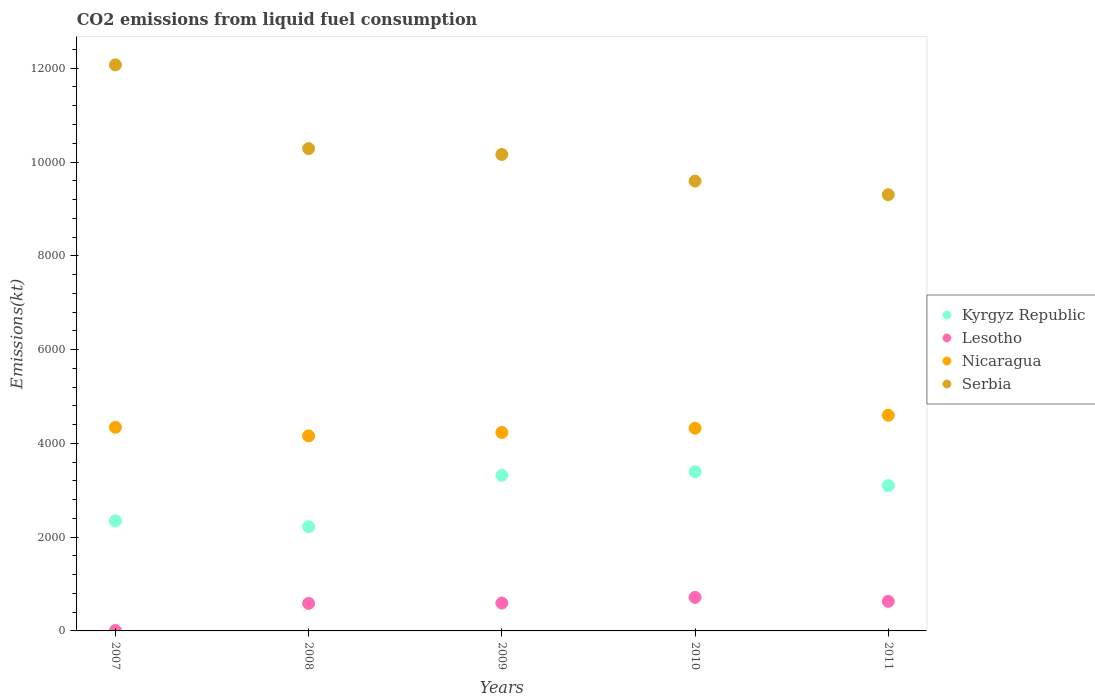What is the amount of CO2 emitted in Kyrgyz Republic in 2007?
Give a very brief answer. 2346.88. Across all years, what is the maximum amount of CO2 emitted in Kyrgyz Republic?
Offer a very short reply. 3395.64. Across all years, what is the minimum amount of CO2 emitted in Kyrgyz Republic?
Offer a very short reply. 2222.2. What is the total amount of CO2 emitted in Serbia in the graph?
Provide a succinct answer. 5.14e+04. What is the difference between the amount of CO2 emitted in Nicaragua in 2010 and that in 2011?
Your answer should be very brief. -275.02. What is the difference between the amount of CO2 emitted in Lesotho in 2010 and the amount of CO2 emitted in Kyrgyz Republic in 2009?
Make the answer very short. -2603.57. What is the average amount of CO2 emitted in Nicaragua per year?
Give a very brief answer. 4330.73. In the year 2007, what is the difference between the amount of CO2 emitted in Nicaragua and amount of CO2 emitted in Serbia?
Keep it short and to the point. -7730.04. What is the ratio of the amount of CO2 emitted in Nicaragua in 2007 to that in 2010?
Your answer should be compact. 1. Is the amount of CO2 emitted in Serbia in 2007 less than that in 2010?
Offer a terse response. No. What is the difference between the highest and the second highest amount of CO2 emitted in Lesotho?
Provide a short and direct response. 84.34. What is the difference between the highest and the lowest amount of CO2 emitted in Nicaragua?
Offer a very short reply. 440.04. Is the sum of the amount of CO2 emitted in Lesotho in 2007 and 2008 greater than the maximum amount of CO2 emitted in Serbia across all years?
Your answer should be compact. No. Is it the case that in every year, the sum of the amount of CO2 emitted in Kyrgyz Republic and amount of CO2 emitted in Serbia  is greater than the amount of CO2 emitted in Lesotho?
Ensure brevity in your answer.  Yes. Is the amount of CO2 emitted in Nicaragua strictly greater than the amount of CO2 emitted in Kyrgyz Republic over the years?
Keep it short and to the point. Yes. Is the amount of CO2 emitted in Nicaragua strictly less than the amount of CO2 emitted in Serbia over the years?
Keep it short and to the point. Yes. How many years are there in the graph?
Offer a very short reply. 5. What is the difference between two consecutive major ticks on the Y-axis?
Provide a short and direct response. 2000. What is the title of the graph?
Give a very brief answer. CO2 emissions from liquid fuel consumption. Does "Italy" appear as one of the legend labels in the graph?
Your answer should be compact. No. What is the label or title of the Y-axis?
Make the answer very short. Emissions(kt). What is the Emissions(kt) in Kyrgyz Republic in 2007?
Provide a short and direct response. 2346.88. What is the Emissions(kt) in Lesotho in 2007?
Make the answer very short. 7.33. What is the Emissions(kt) of Nicaragua in 2007?
Provide a short and direct response. 4341.73. What is the Emissions(kt) of Serbia in 2007?
Make the answer very short. 1.21e+04. What is the Emissions(kt) in Kyrgyz Republic in 2008?
Your answer should be very brief. 2222.2. What is the Emissions(kt) in Lesotho in 2008?
Offer a terse response. 586.72. What is the Emissions(kt) of Nicaragua in 2008?
Give a very brief answer. 4158.38. What is the Emissions(kt) of Serbia in 2008?
Provide a short and direct response. 1.03e+04. What is the Emissions(kt) in Kyrgyz Republic in 2009?
Make the answer very short. 3318.64. What is the Emissions(kt) in Lesotho in 2009?
Offer a very short reply. 594.05. What is the Emissions(kt) of Nicaragua in 2009?
Keep it short and to the point. 4231.72. What is the Emissions(kt) in Serbia in 2009?
Your answer should be compact. 1.02e+04. What is the Emissions(kt) of Kyrgyz Republic in 2010?
Make the answer very short. 3395.64. What is the Emissions(kt) of Lesotho in 2010?
Your answer should be compact. 715.07. What is the Emissions(kt) of Nicaragua in 2010?
Keep it short and to the point. 4323.39. What is the Emissions(kt) of Serbia in 2010?
Your answer should be very brief. 9592.87. What is the Emissions(kt) of Kyrgyz Republic in 2011?
Keep it short and to the point. 3098.61. What is the Emissions(kt) of Lesotho in 2011?
Your answer should be compact. 630.72. What is the Emissions(kt) in Nicaragua in 2011?
Your response must be concise. 4598.42. What is the Emissions(kt) in Serbia in 2011?
Your answer should be very brief. 9303.18. Across all years, what is the maximum Emissions(kt) of Kyrgyz Republic?
Offer a terse response. 3395.64. Across all years, what is the maximum Emissions(kt) of Lesotho?
Give a very brief answer. 715.07. Across all years, what is the maximum Emissions(kt) in Nicaragua?
Provide a succinct answer. 4598.42. Across all years, what is the maximum Emissions(kt) in Serbia?
Offer a terse response. 1.21e+04. Across all years, what is the minimum Emissions(kt) in Kyrgyz Republic?
Your answer should be very brief. 2222.2. Across all years, what is the minimum Emissions(kt) in Lesotho?
Give a very brief answer. 7.33. Across all years, what is the minimum Emissions(kt) in Nicaragua?
Make the answer very short. 4158.38. Across all years, what is the minimum Emissions(kt) of Serbia?
Offer a terse response. 9303.18. What is the total Emissions(kt) in Kyrgyz Republic in the graph?
Offer a terse response. 1.44e+04. What is the total Emissions(kt) in Lesotho in the graph?
Your answer should be very brief. 2533.9. What is the total Emissions(kt) in Nicaragua in the graph?
Provide a succinct answer. 2.17e+04. What is the total Emissions(kt) in Serbia in the graph?
Your response must be concise. 5.14e+04. What is the difference between the Emissions(kt) in Kyrgyz Republic in 2007 and that in 2008?
Your answer should be very brief. 124.68. What is the difference between the Emissions(kt) in Lesotho in 2007 and that in 2008?
Offer a terse response. -579.39. What is the difference between the Emissions(kt) in Nicaragua in 2007 and that in 2008?
Your answer should be very brief. 183.35. What is the difference between the Emissions(kt) in Serbia in 2007 and that in 2008?
Provide a short and direct response. 1785.83. What is the difference between the Emissions(kt) in Kyrgyz Republic in 2007 and that in 2009?
Offer a terse response. -971.75. What is the difference between the Emissions(kt) of Lesotho in 2007 and that in 2009?
Provide a succinct answer. -586.72. What is the difference between the Emissions(kt) of Nicaragua in 2007 and that in 2009?
Provide a succinct answer. 110.01. What is the difference between the Emissions(kt) in Serbia in 2007 and that in 2009?
Ensure brevity in your answer.  1910.51. What is the difference between the Emissions(kt) in Kyrgyz Republic in 2007 and that in 2010?
Your answer should be compact. -1048.76. What is the difference between the Emissions(kt) of Lesotho in 2007 and that in 2010?
Your answer should be compact. -707.73. What is the difference between the Emissions(kt) of Nicaragua in 2007 and that in 2010?
Your answer should be compact. 18.34. What is the difference between the Emissions(kt) in Serbia in 2007 and that in 2010?
Give a very brief answer. 2478.89. What is the difference between the Emissions(kt) in Kyrgyz Republic in 2007 and that in 2011?
Offer a very short reply. -751.74. What is the difference between the Emissions(kt) in Lesotho in 2007 and that in 2011?
Offer a very short reply. -623.39. What is the difference between the Emissions(kt) of Nicaragua in 2007 and that in 2011?
Offer a very short reply. -256.69. What is the difference between the Emissions(kt) of Serbia in 2007 and that in 2011?
Ensure brevity in your answer.  2768.59. What is the difference between the Emissions(kt) in Kyrgyz Republic in 2008 and that in 2009?
Your answer should be very brief. -1096.43. What is the difference between the Emissions(kt) of Lesotho in 2008 and that in 2009?
Offer a terse response. -7.33. What is the difference between the Emissions(kt) in Nicaragua in 2008 and that in 2009?
Your answer should be compact. -73.34. What is the difference between the Emissions(kt) in Serbia in 2008 and that in 2009?
Keep it short and to the point. 124.68. What is the difference between the Emissions(kt) in Kyrgyz Republic in 2008 and that in 2010?
Offer a very short reply. -1173.44. What is the difference between the Emissions(kt) in Lesotho in 2008 and that in 2010?
Offer a very short reply. -128.34. What is the difference between the Emissions(kt) of Nicaragua in 2008 and that in 2010?
Give a very brief answer. -165.01. What is the difference between the Emissions(kt) in Serbia in 2008 and that in 2010?
Your answer should be very brief. 693.06. What is the difference between the Emissions(kt) in Kyrgyz Republic in 2008 and that in 2011?
Offer a terse response. -876.41. What is the difference between the Emissions(kt) of Lesotho in 2008 and that in 2011?
Provide a succinct answer. -44. What is the difference between the Emissions(kt) of Nicaragua in 2008 and that in 2011?
Provide a short and direct response. -440.04. What is the difference between the Emissions(kt) in Serbia in 2008 and that in 2011?
Ensure brevity in your answer.  982.76. What is the difference between the Emissions(kt) in Kyrgyz Republic in 2009 and that in 2010?
Ensure brevity in your answer.  -77.01. What is the difference between the Emissions(kt) of Lesotho in 2009 and that in 2010?
Give a very brief answer. -121.01. What is the difference between the Emissions(kt) of Nicaragua in 2009 and that in 2010?
Your answer should be very brief. -91.67. What is the difference between the Emissions(kt) in Serbia in 2009 and that in 2010?
Give a very brief answer. 568.38. What is the difference between the Emissions(kt) in Kyrgyz Republic in 2009 and that in 2011?
Keep it short and to the point. 220.02. What is the difference between the Emissions(kt) in Lesotho in 2009 and that in 2011?
Make the answer very short. -36.67. What is the difference between the Emissions(kt) of Nicaragua in 2009 and that in 2011?
Ensure brevity in your answer.  -366.7. What is the difference between the Emissions(kt) of Serbia in 2009 and that in 2011?
Offer a terse response. 858.08. What is the difference between the Emissions(kt) of Kyrgyz Republic in 2010 and that in 2011?
Keep it short and to the point. 297.03. What is the difference between the Emissions(kt) of Lesotho in 2010 and that in 2011?
Make the answer very short. 84.34. What is the difference between the Emissions(kt) in Nicaragua in 2010 and that in 2011?
Provide a succinct answer. -275.02. What is the difference between the Emissions(kt) in Serbia in 2010 and that in 2011?
Ensure brevity in your answer.  289.69. What is the difference between the Emissions(kt) in Kyrgyz Republic in 2007 and the Emissions(kt) in Lesotho in 2008?
Your response must be concise. 1760.16. What is the difference between the Emissions(kt) in Kyrgyz Republic in 2007 and the Emissions(kt) in Nicaragua in 2008?
Give a very brief answer. -1811.5. What is the difference between the Emissions(kt) of Kyrgyz Republic in 2007 and the Emissions(kt) of Serbia in 2008?
Provide a short and direct response. -7939.06. What is the difference between the Emissions(kt) of Lesotho in 2007 and the Emissions(kt) of Nicaragua in 2008?
Ensure brevity in your answer.  -4151.04. What is the difference between the Emissions(kt) of Lesotho in 2007 and the Emissions(kt) of Serbia in 2008?
Your answer should be very brief. -1.03e+04. What is the difference between the Emissions(kt) in Nicaragua in 2007 and the Emissions(kt) in Serbia in 2008?
Offer a terse response. -5944.21. What is the difference between the Emissions(kt) in Kyrgyz Republic in 2007 and the Emissions(kt) in Lesotho in 2009?
Provide a succinct answer. 1752.83. What is the difference between the Emissions(kt) in Kyrgyz Republic in 2007 and the Emissions(kt) in Nicaragua in 2009?
Keep it short and to the point. -1884.84. What is the difference between the Emissions(kt) in Kyrgyz Republic in 2007 and the Emissions(kt) in Serbia in 2009?
Provide a succinct answer. -7814.38. What is the difference between the Emissions(kt) in Lesotho in 2007 and the Emissions(kt) in Nicaragua in 2009?
Provide a short and direct response. -4224.38. What is the difference between the Emissions(kt) of Lesotho in 2007 and the Emissions(kt) of Serbia in 2009?
Your answer should be very brief. -1.02e+04. What is the difference between the Emissions(kt) in Nicaragua in 2007 and the Emissions(kt) in Serbia in 2009?
Ensure brevity in your answer.  -5819.53. What is the difference between the Emissions(kt) of Kyrgyz Republic in 2007 and the Emissions(kt) of Lesotho in 2010?
Offer a very short reply. 1631.82. What is the difference between the Emissions(kt) of Kyrgyz Republic in 2007 and the Emissions(kt) of Nicaragua in 2010?
Provide a short and direct response. -1976.51. What is the difference between the Emissions(kt) in Kyrgyz Republic in 2007 and the Emissions(kt) in Serbia in 2010?
Offer a very short reply. -7245.99. What is the difference between the Emissions(kt) of Lesotho in 2007 and the Emissions(kt) of Nicaragua in 2010?
Your answer should be compact. -4316.06. What is the difference between the Emissions(kt) in Lesotho in 2007 and the Emissions(kt) in Serbia in 2010?
Your answer should be very brief. -9585.54. What is the difference between the Emissions(kt) in Nicaragua in 2007 and the Emissions(kt) in Serbia in 2010?
Ensure brevity in your answer.  -5251.14. What is the difference between the Emissions(kt) of Kyrgyz Republic in 2007 and the Emissions(kt) of Lesotho in 2011?
Give a very brief answer. 1716.16. What is the difference between the Emissions(kt) of Kyrgyz Republic in 2007 and the Emissions(kt) of Nicaragua in 2011?
Give a very brief answer. -2251.54. What is the difference between the Emissions(kt) in Kyrgyz Republic in 2007 and the Emissions(kt) in Serbia in 2011?
Offer a terse response. -6956.3. What is the difference between the Emissions(kt) of Lesotho in 2007 and the Emissions(kt) of Nicaragua in 2011?
Ensure brevity in your answer.  -4591.08. What is the difference between the Emissions(kt) in Lesotho in 2007 and the Emissions(kt) in Serbia in 2011?
Your answer should be very brief. -9295.84. What is the difference between the Emissions(kt) in Nicaragua in 2007 and the Emissions(kt) in Serbia in 2011?
Your answer should be very brief. -4961.45. What is the difference between the Emissions(kt) in Kyrgyz Republic in 2008 and the Emissions(kt) in Lesotho in 2009?
Ensure brevity in your answer.  1628.15. What is the difference between the Emissions(kt) of Kyrgyz Republic in 2008 and the Emissions(kt) of Nicaragua in 2009?
Provide a succinct answer. -2009.52. What is the difference between the Emissions(kt) of Kyrgyz Republic in 2008 and the Emissions(kt) of Serbia in 2009?
Keep it short and to the point. -7939.06. What is the difference between the Emissions(kt) in Lesotho in 2008 and the Emissions(kt) in Nicaragua in 2009?
Offer a terse response. -3645. What is the difference between the Emissions(kt) in Lesotho in 2008 and the Emissions(kt) in Serbia in 2009?
Ensure brevity in your answer.  -9574.54. What is the difference between the Emissions(kt) in Nicaragua in 2008 and the Emissions(kt) in Serbia in 2009?
Your answer should be compact. -6002.88. What is the difference between the Emissions(kt) in Kyrgyz Republic in 2008 and the Emissions(kt) in Lesotho in 2010?
Your answer should be very brief. 1507.14. What is the difference between the Emissions(kt) of Kyrgyz Republic in 2008 and the Emissions(kt) of Nicaragua in 2010?
Ensure brevity in your answer.  -2101.19. What is the difference between the Emissions(kt) of Kyrgyz Republic in 2008 and the Emissions(kt) of Serbia in 2010?
Provide a succinct answer. -7370.67. What is the difference between the Emissions(kt) of Lesotho in 2008 and the Emissions(kt) of Nicaragua in 2010?
Give a very brief answer. -3736.67. What is the difference between the Emissions(kt) of Lesotho in 2008 and the Emissions(kt) of Serbia in 2010?
Provide a short and direct response. -9006.15. What is the difference between the Emissions(kt) of Nicaragua in 2008 and the Emissions(kt) of Serbia in 2010?
Your answer should be compact. -5434.49. What is the difference between the Emissions(kt) in Kyrgyz Republic in 2008 and the Emissions(kt) in Lesotho in 2011?
Give a very brief answer. 1591.48. What is the difference between the Emissions(kt) in Kyrgyz Republic in 2008 and the Emissions(kt) in Nicaragua in 2011?
Provide a succinct answer. -2376.22. What is the difference between the Emissions(kt) in Kyrgyz Republic in 2008 and the Emissions(kt) in Serbia in 2011?
Your answer should be compact. -7080.98. What is the difference between the Emissions(kt) in Lesotho in 2008 and the Emissions(kt) in Nicaragua in 2011?
Your response must be concise. -4011.7. What is the difference between the Emissions(kt) in Lesotho in 2008 and the Emissions(kt) in Serbia in 2011?
Your answer should be compact. -8716.46. What is the difference between the Emissions(kt) in Nicaragua in 2008 and the Emissions(kt) in Serbia in 2011?
Provide a short and direct response. -5144.8. What is the difference between the Emissions(kt) of Kyrgyz Republic in 2009 and the Emissions(kt) of Lesotho in 2010?
Make the answer very short. 2603.57. What is the difference between the Emissions(kt) in Kyrgyz Republic in 2009 and the Emissions(kt) in Nicaragua in 2010?
Ensure brevity in your answer.  -1004.76. What is the difference between the Emissions(kt) in Kyrgyz Republic in 2009 and the Emissions(kt) in Serbia in 2010?
Give a very brief answer. -6274.24. What is the difference between the Emissions(kt) of Lesotho in 2009 and the Emissions(kt) of Nicaragua in 2010?
Your answer should be compact. -3729.34. What is the difference between the Emissions(kt) of Lesotho in 2009 and the Emissions(kt) of Serbia in 2010?
Provide a short and direct response. -8998.82. What is the difference between the Emissions(kt) in Nicaragua in 2009 and the Emissions(kt) in Serbia in 2010?
Your answer should be compact. -5361.15. What is the difference between the Emissions(kt) in Kyrgyz Republic in 2009 and the Emissions(kt) in Lesotho in 2011?
Offer a very short reply. 2687.91. What is the difference between the Emissions(kt) of Kyrgyz Republic in 2009 and the Emissions(kt) of Nicaragua in 2011?
Your answer should be very brief. -1279.78. What is the difference between the Emissions(kt) in Kyrgyz Republic in 2009 and the Emissions(kt) in Serbia in 2011?
Keep it short and to the point. -5984.54. What is the difference between the Emissions(kt) of Lesotho in 2009 and the Emissions(kt) of Nicaragua in 2011?
Make the answer very short. -4004.36. What is the difference between the Emissions(kt) in Lesotho in 2009 and the Emissions(kt) in Serbia in 2011?
Offer a very short reply. -8709.12. What is the difference between the Emissions(kt) in Nicaragua in 2009 and the Emissions(kt) in Serbia in 2011?
Keep it short and to the point. -5071.46. What is the difference between the Emissions(kt) of Kyrgyz Republic in 2010 and the Emissions(kt) of Lesotho in 2011?
Provide a succinct answer. 2764.92. What is the difference between the Emissions(kt) in Kyrgyz Republic in 2010 and the Emissions(kt) in Nicaragua in 2011?
Offer a terse response. -1202.78. What is the difference between the Emissions(kt) of Kyrgyz Republic in 2010 and the Emissions(kt) of Serbia in 2011?
Your answer should be very brief. -5907.54. What is the difference between the Emissions(kt) of Lesotho in 2010 and the Emissions(kt) of Nicaragua in 2011?
Ensure brevity in your answer.  -3883.35. What is the difference between the Emissions(kt) in Lesotho in 2010 and the Emissions(kt) in Serbia in 2011?
Give a very brief answer. -8588.11. What is the difference between the Emissions(kt) of Nicaragua in 2010 and the Emissions(kt) of Serbia in 2011?
Ensure brevity in your answer.  -4979.79. What is the average Emissions(kt) in Kyrgyz Republic per year?
Ensure brevity in your answer.  2876.39. What is the average Emissions(kt) in Lesotho per year?
Make the answer very short. 506.78. What is the average Emissions(kt) in Nicaragua per year?
Your answer should be very brief. 4330.73. What is the average Emissions(kt) of Serbia per year?
Give a very brief answer. 1.03e+04. In the year 2007, what is the difference between the Emissions(kt) in Kyrgyz Republic and Emissions(kt) in Lesotho?
Ensure brevity in your answer.  2339.55. In the year 2007, what is the difference between the Emissions(kt) in Kyrgyz Republic and Emissions(kt) in Nicaragua?
Offer a very short reply. -1994.85. In the year 2007, what is the difference between the Emissions(kt) in Kyrgyz Republic and Emissions(kt) in Serbia?
Your answer should be very brief. -9724.88. In the year 2007, what is the difference between the Emissions(kt) in Lesotho and Emissions(kt) in Nicaragua?
Ensure brevity in your answer.  -4334.39. In the year 2007, what is the difference between the Emissions(kt) of Lesotho and Emissions(kt) of Serbia?
Your response must be concise. -1.21e+04. In the year 2007, what is the difference between the Emissions(kt) of Nicaragua and Emissions(kt) of Serbia?
Ensure brevity in your answer.  -7730.04. In the year 2008, what is the difference between the Emissions(kt) in Kyrgyz Republic and Emissions(kt) in Lesotho?
Ensure brevity in your answer.  1635.48. In the year 2008, what is the difference between the Emissions(kt) of Kyrgyz Republic and Emissions(kt) of Nicaragua?
Keep it short and to the point. -1936.18. In the year 2008, what is the difference between the Emissions(kt) of Kyrgyz Republic and Emissions(kt) of Serbia?
Give a very brief answer. -8063.73. In the year 2008, what is the difference between the Emissions(kt) in Lesotho and Emissions(kt) in Nicaragua?
Provide a succinct answer. -3571.66. In the year 2008, what is the difference between the Emissions(kt) in Lesotho and Emissions(kt) in Serbia?
Provide a succinct answer. -9699.22. In the year 2008, what is the difference between the Emissions(kt) of Nicaragua and Emissions(kt) of Serbia?
Your answer should be compact. -6127.56. In the year 2009, what is the difference between the Emissions(kt) of Kyrgyz Republic and Emissions(kt) of Lesotho?
Your answer should be very brief. 2724.58. In the year 2009, what is the difference between the Emissions(kt) in Kyrgyz Republic and Emissions(kt) in Nicaragua?
Your answer should be very brief. -913.08. In the year 2009, what is the difference between the Emissions(kt) of Kyrgyz Republic and Emissions(kt) of Serbia?
Provide a short and direct response. -6842.62. In the year 2009, what is the difference between the Emissions(kt) of Lesotho and Emissions(kt) of Nicaragua?
Offer a terse response. -3637.66. In the year 2009, what is the difference between the Emissions(kt) of Lesotho and Emissions(kt) of Serbia?
Your answer should be very brief. -9567.2. In the year 2009, what is the difference between the Emissions(kt) in Nicaragua and Emissions(kt) in Serbia?
Make the answer very short. -5929.54. In the year 2010, what is the difference between the Emissions(kt) of Kyrgyz Republic and Emissions(kt) of Lesotho?
Make the answer very short. 2680.58. In the year 2010, what is the difference between the Emissions(kt) of Kyrgyz Republic and Emissions(kt) of Nicaragua?
Offer a very short reply. -927.75. In the year 2010, what is the difference between the Emissions(kt) of Kyrgyz Republic and Emissions(kt) of Serbia?
Make the answer very short. -6197.23. In the year 2010, what is the difference between the Emissions(kt) in Lesotho and Emissions(kt) in Nicaragua?
Your answer should be compact. -3608.33. In the year 2010, what is the difference between the Emissions(kt) of Lesotho and Emissions(kt) of Serbia?
Your answer should be very brief. -8877.81. In the year 2010, what is the difference between the Emissions(kt) in Nicaragua and Emissions(kt) in Serbia?
Give a very brief answer. -5269.48. In the year 2011, what is the difference between the Emissions(kt) of Kyrgyz Republic and Emissions(kt) of Lesotho?
Your response must be concise. 2467.89. In the year 2011, what is the difference between the Emissions(kt) of Kyrgyz Republic and Emissions(kt) of Nicaragua?
Provide a succinct answer. -1499.8. In the year 2011, what is the difference between the Emissions(kt) in Kyrgyz Republic and Emissions(kt) in Serbia?
Give a very brief answer. -6204.56. In the year 2011, what is the difference between the Emissions(kt) in Lesotho and Emissions(kt) in Nicaragua?
Offer a terse response. -3967.69. In the year 2011, what is the difference between the Emissions(kt) of Lesotho and Emissions(kt) of Serbia?
Your answer should be compact. -8672.45. In the year 2011, what is the difference between the Emissions(kt) in Nicaragua and Emissions(kt) in Serbia?
Offer a terse response. -4704.76. What is the ratio of the Emissions(kt) of Kyrgyz Republic in 2007 to that in 2008?
Ensure brevity in your answer.  1.06. What is the ratio of the Emissions(kt) in Lesotho in 2007 to that in 2008?
Offer a terse response. 0.01. What is the ratio of the Emissions(kt) of Nicaragua in 2007 to that in 2008?
Offer a terse response. 1.04. What is the ratio of the Emissions(kt) of Serbia in 2007 to that in 2008?
Offer a very short reply. 1.17. What is the ratio of the Emissions(kt) of Kyrgyz Republic in 2007 to that in 2009?
Your answer should be compact. 0.71. What is the ratio of the Emissions(kt) of Lesotho in 2007 to that in 2009?
Offer a terse response. 0.01. What is the ratio of the Emissions(kt) of Serbia in 2007 to that in 2009?
Keep it short and to the point. 1.19. What is the ratio of the Emissions(kt) in Kyrgyz Republic in 2007 to that in 2010?
Your response must be concise. 0.69. What is the ratio of the Emissions(kt) in Lesotho in 2007 to that in 2010?
Your response must be concise. 0.01. What is the ratio of the Emissions(kt) in Serbia in 2007 to that in 2010?
Ensure brevity in your answer.  1.26. What is the ratio of the Emissions(kt) in Kyrgyz Republic in 2007 to that in 2011?
Offer a very short reply. 0.76. What is the ratio of the Emissions(kt) in Lesotho in 2007 to that in 2011?
Make the answer very short. 0.01. What is the ratio of the Emissions(kt) in Nicaragua in 2007 to that in 2011?
Your answer should be very brief. 0.94. What is the ratio of the Emissions(kt) in Serbia in 2007 to that in 2011?
Offer a very short reply. 1.3. What is the ratio of the Emissions(kt) of Kyrgyz Republic in 2008 to that in 2009?
Your answer should be compact. 0.67. What is the ratio of the Emissions(kt) in Lesotho in 2008 to that in 2009?
Your answer should be very brief. 0.99. What is the ratio of the Emissions(kt) of Nicaragua in 2008 to that in 2009?
Provide a succinct answer. 0.98. What is the ratio of the Emissions(kt) of Serbia in 2008 to that in 2009?
Offer a very short reply. 1.01. What is the ratio of the Emissions(kt) of Kyrgyz Republic in 2008 to that in 2010?
Make the answer very short. 0.65. What is the ratio of the Emissions(kt) of Lesotho in 2008 to that in 2010?
Offer a terse response. 0.82. What is the ratio of the Emissions(kt) in Nicaragua in 2008 to that in 2010?
Ensure brevity in your answer.  0.96. What is the ratio of the Emissions(kt) of Serbia in 2008 to that in 2010?
Your response must be concise. 1.07. What is the ratio of the Emissions(kt) of Kyrgyz Republic in 2008 to that in 2011?
Give a very brief answer. 0.72. What is the ratio of the Emissions(kt) in Lesotho in 2008 to that in 2011?
Make the answer very short. 0.93. What is the ratio of the Emissions(kt) of Nicaragua in 2008 to that in 2011?
Give a very brief answer. 0.9. What is the ratio of the Emissions(kt) of Serbia in 2008 to that in 2011?
Your answer should be compact. 1.11. What is the ratio of the Emissions(kt) in Kyrgyz Republic in 2009 to that in 2010?
Ensure brevity in your answer.  0.98. What is the ratio of the Emissions(kt) of Lesotho in 2009 to that in 2010?
Offer a terse response. 0.83. What is the ratio of the Emissions(kt) of Nicaragua in 2009 to that in 2010?
Your answer should be very brief. 0.98. What is the ratio of the Emissions(kt) of Serbia in 2009 to that in 2010?
Provide a short and direct response. 1.06. What is the ratio of the Emissions(kt) of Kyrgyz Republic in 2009 to that in 2011?
Keep it short and to the point. 1.07. What is the ratio of the Emissions(kt) of Lesotho in 2009 to that in 2011?
Offer a terse response. 0.94. What is the ratio of the Emissions(kt) in Nicaragua in 2009 to that in 2011?
Provide a short and direct response. 0.92. What is the ratio of the Emissions(kt) of Serbia in 2009 to that in 2011?
Make the answer very short. 1.09. What is the ratio of the Emissions(kt) in Kyrgyz Republic in 2010 to that in 2011?
Make the answer very short. 1.1. What is the ratio of the Emissions(kt) of Lesotho in 2010 to that in 2011?
Provide a succinct answer. 1.13. What is the ratio of the Emissions(kt) of Nicaragua in 2010 to that in 2011?
Provide a succinct answer. 0.94. What is the ratio of the Emissions(kt) in Serbia in 2010 to that in 2011?
Provide a succinct answer. 1.03. What is the difference between the highest and the second highest Emissions(kt) of Kyrgyz Republic?
Keep it short and to the point. 77.01. What is the difference between the highest and the second highest Emissions(kt) of Lesotho?
Provide a succinct answer. 84.34. What is the difference between the highest and the second highest Emissions(kt) in Nicaragua?
Keep it short and to the point. 256.69. What is the difference between the highest and the second highest Emissions(kt) of Serbia?
Make the answer very short. 1785.83. What is the difference between the highest and the lowest Emissions(kt) in Kyrgyz Republic?
Keep it short and to the point. 1173.44. What is the difference between the highest and the lowest Emissions(kt) of Lesotho?
Provide a short and direct response. 707.73. What is the difference between the highest and the lowest Emissions(kt) of Nicaragua?
Provide a short and direct response. 440.04. What is the difference between the highest and the lowest Emissions(kt) of Serbia?
Offer a very short reply. 2768.59. 